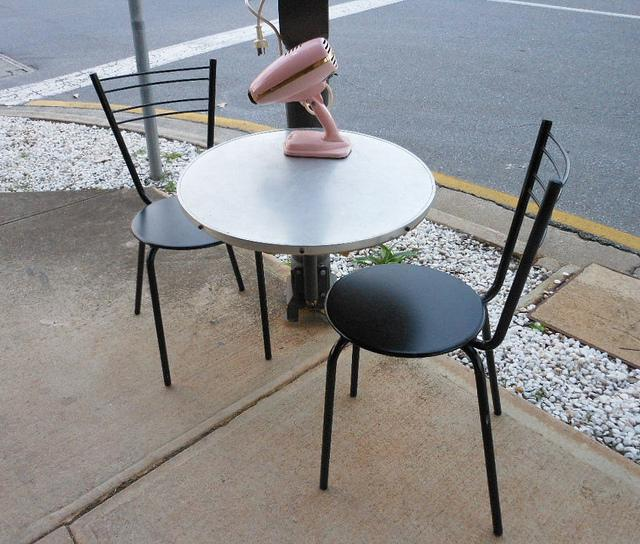What type of electronic is on the table? Please explain your reasoning. hair dryer. The item sitting on the table is a hair dryer since it has an oblong shape. 